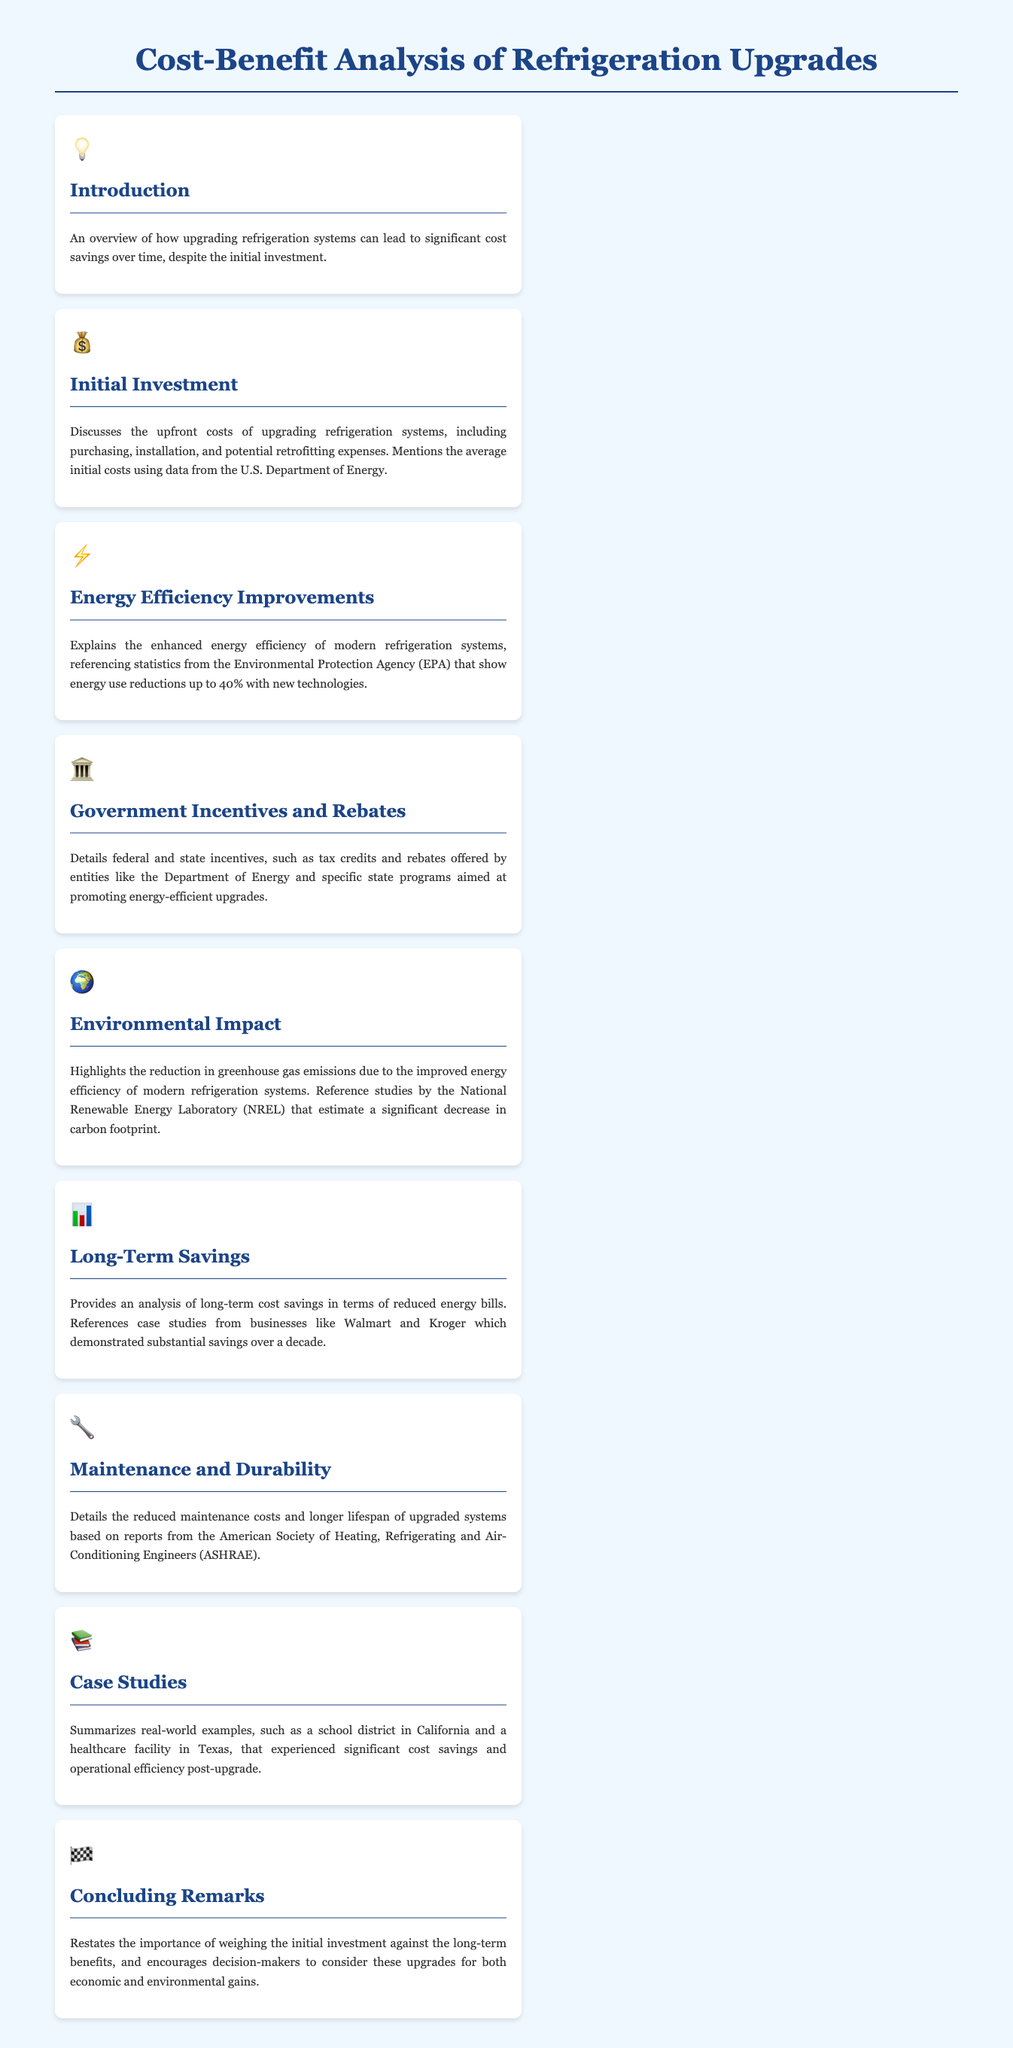What is the main topic of the infographic? The infographic discusses the cost-benefit analysis related to refrigeration upgrades.
Answer: Cost-Benefit Analysis of Refrigeration Upgrades What percentage of energy use reductions is referenced? The document mentions energy use reductions up to 40% with new technologies.
Answer: 40% Which organization provides information on government incentives? It mentions incentives provided by the Department of Energy and specific state programs.
Answer: Department of Energy What is a key environmental benefit highlighted in the document? The infographic emphasizes the reduction in greenhouse gas emissions due to improved energy efficiency.
Answer: Reduction in greenhouse gas emissions What significant savings did businesses like Walmart and Kroger experience? The case studies reference substantial savings over a decade.
Answer: Substantial savings over a decade Which engineering society is cited for information about maintenance costs? The document references reports from the American Society of Heating, Refrigerating and Air-Conditioning Engineers.
Answer: American Society of Heating, Refrigerating and Air-Conditioning Engineers What is the conclusion's call to action for decision-makers? It encourages decision-makers to consider upgrades for economic and environmental gains.
Answer: Consider these upgrades What type of examples does the Case Studies section provide? The section summarizes real-world examples of cost savings and operational efficiency.
Answer: Real-world examples 